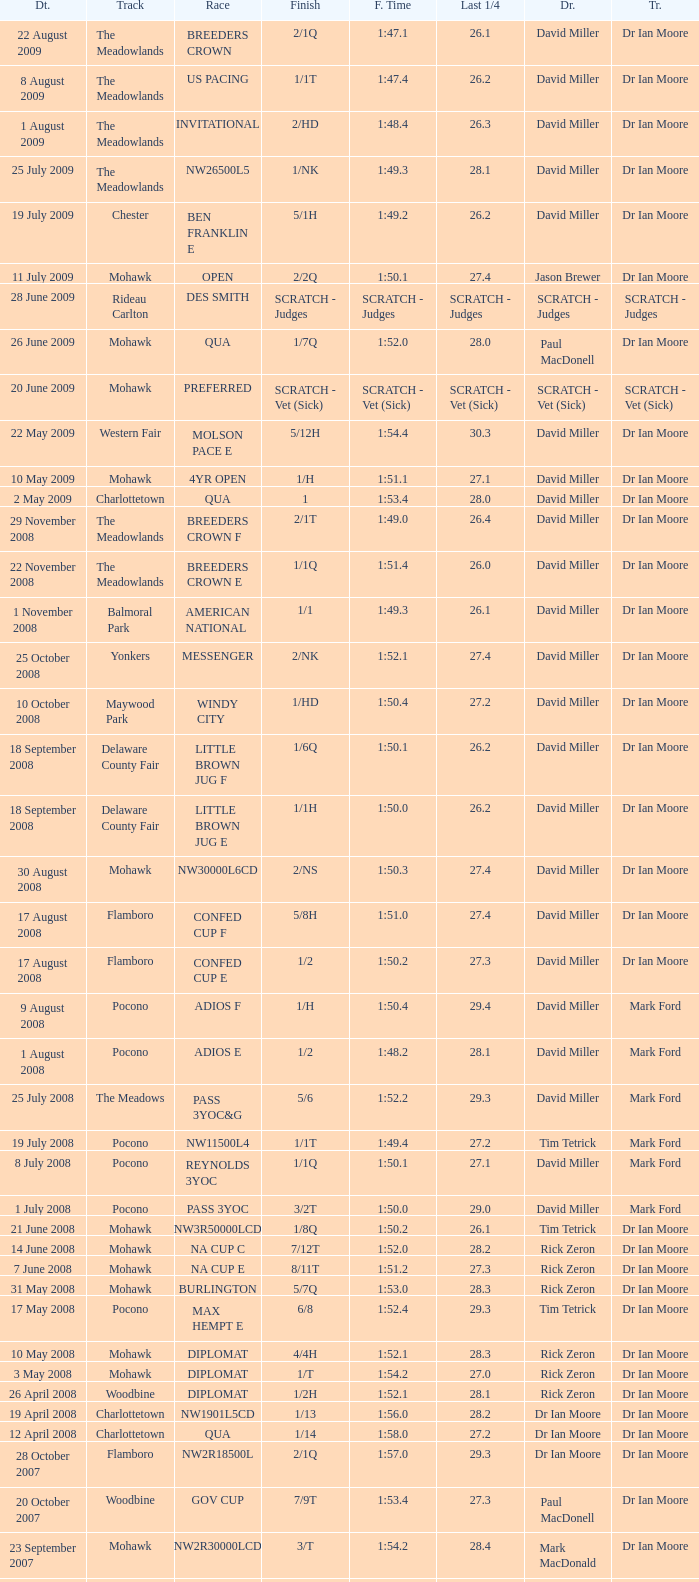What is the last 1/4 for the QUA race with a finishing time of 2:03.1? 29.2. 